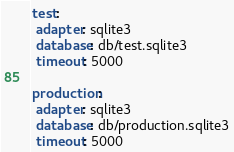Convert code to text. <code><loc_0><loc_0><loc_500><loc_500><_YAML_>test:
 adapter: sqlite3
 database: db/test.sqlite3
 timeout: 5000

production:
 adapter: sqlite3
 database: db/production.sqlite3
 timeout: 5000
</code> 